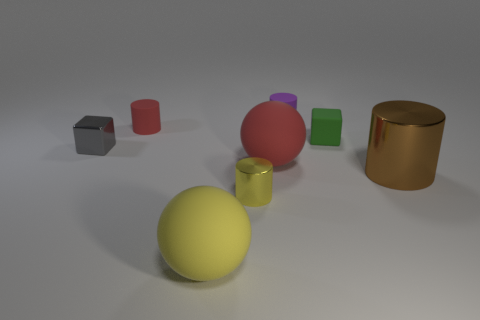What number of other objects are the same material as the big red ball?
Give a very brief answer. 4. There is a red thing that is in front of the tiny gray metal block; does it have the same shape as the big yellow matte thing?
Make the answer very short. Yes. Are any small gray matte objects visible?
Provide a short and direct response. No. Are there more tiny metal things that are in front of the big brown object than green cylinders?
Ensure brevity in your answer.  Yes. Are there any large cylinders behind the red matte cylinder?
Offer a very short reply. No. Is the green block the same size as the red rubber cylinder?
Your answer should be compact. Yes. What size is the gray object that is the same shape as the tiny green thing?
Your answer should be very brief. Small. Are there any other things that have the same size as the brown cylinder?
Provide a succinct answer. Yes. What material is the small block that is behind the shiny object that is behind the brown metallic object made of?
Offer a very short reply. Rubber. Is the shape of the brown shiny thing the same as the green rubber thing?
Keep it short and to the point. No. 